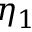<formula> <loc_0><loc_0><loc_500><loc_500>\eta _ { 1 }</formula> 